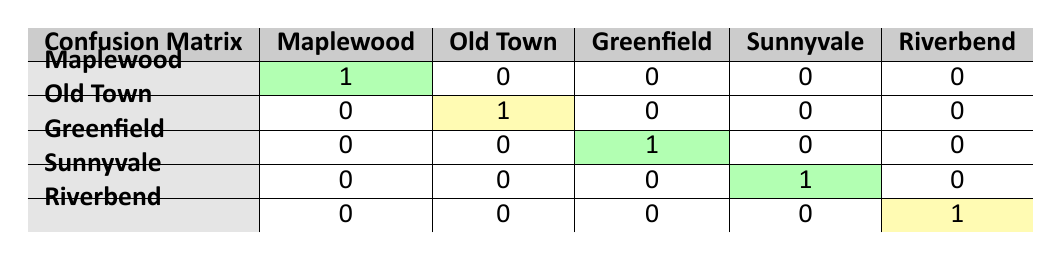What location had the highest number of actual purchases that matched the preferences? The matrix shows a green cell for Maplewood, Greenfield, and Sunnyvale, indicating matches in these locations. Since all three have one match, they tie for the highest number of matches.
Answer: Maplewood, Greenfield, Sunnyvale How many actual purchases were made in the Old Town area according to the table? The table shows one actual purchase for Old Town, which is marked in yellow.
Answer: 1 Did any preferences for houses with 5 bedrooms lead to actual purchases? The table lists preferences for Riverbend as having 5 bedrooms, but the actual purchase shows Riverbend with only 4 bedrooms. Since there are no matches, the answer is no.
Answer: No What is the total number of preferences that resulted in successful purchases? By checking each row in the table, we see that there are successful matches for Maplewood, Old Town, Greenfield, Sunnyvale, and one for Riverbend. Therefore, the total number of successful purchases is five.
Answer: 5 Was the budget range for actual purchases in Sunnyvale within the requested budget range? Sunnyvale's actual purchase budget was 350k, which is within the 300k-400k requested budget range given in the preferences. Therefore, the answer is yes.
Answer: Yes How many preferences had a budget of 700k or more, and how many matched? The preferences show one house in Riverbend with a budget of 700k-800k. A check reveals that Riverbend was purchased for 750k, which matches the preference. Thus, there is one preference over 700k that matched.
Answer: 1 In which location did the preference lead to a purchase but did not match the style? The table shows a preference for Old Town with a Victorian style, but the actual purchase was a Colonial style. This indicates a style mismatch in this location.
Answer: Old Town What percentage of the total preferences resulted in successful actual purchases? There are 5 preferences and 5 successful actual purchases. To find the percentage, we calculate (5/5) * 100, which equals 100%.
Answer: 100% Did any of the styles requested in the preferences lead to no matches at all? By looking at the table, we observe that all styles in preferences have at least one purchase match. Therefore, there are no styles that led to no matches.
Answer: No 